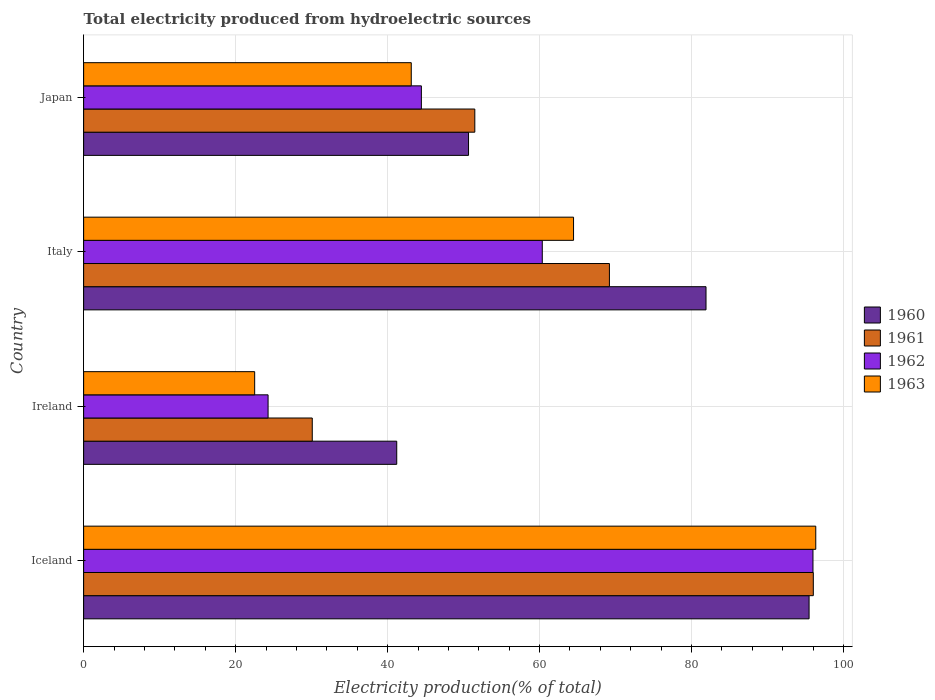How many groups of bars are there?
Give a very brief answer. 4. Are the number of bars per tick equal to the number of legend labels?
Provide a short and direct response. Yes. Are the number of bars on each tick of the Y-axis equal?
Keep it short and to the point. Yes. What is the label of the 3rd group of bars from the top?
Make the answer very short. Ireland. What is the total electricity produced in 1961 in Iceland?
Your answer should be very brief. 96.02. Across all countries, what is the maximum total electricity produced in 1962?
Your answer should be compact. 95.97. Across all countries, what is the minimum total electricity produced in 1962?
Offer a very short reply. 24.27. In which country was the total electricity produced in 1963 minimum?
Your response must be concise. Ireland. What is the total total electricity produced in 1960 in the graph?
Ensure brevity in your answer.  269.21. What is the difference between the total electricity produced in 1960 in Italy and that in Japan?
Your answer should be compact. 31.25. What is the difference between the total electricity produced in 1962 in Japan and the total electricity produced in 1960 in Iceland?
Offer a terse response. -51.02. What is the average total electricity produced in 1960 per country?
Provide a short and direct response. 67.3. What is the difference between the total electricity produced in 1963 and total electricity produced in 1962 in Ireland?
Make the answer very short. -1.76. What is the ratio of the total electricity produced in 1960 in Iceland to that in Japan?
Your answer should be compact. 1.88. What is the difference between the highest and the second highest total electricity produced in 1963?
Your answer should be very brief. 31.87. What is the difference between the highest and the lowest total electricity produced in 1963?
Your answer should be very brief. 73.83. Is the sum of the total electricity produced in 1961 in Italy and Japan greater than the maximum total electricity produced in 1963 across all countries?
Provide a short and direct response. Yes. What does the 3rd bar from the top in Japan represents?
Provide a succinct answer. 1961. Is it the case that in every country, the sum of the total electricity produced in 1962 and total electricity produced in 1963 is greater than the total electricity produced in 1960?
Offer a terse response. Yes. How are the legend labels stacked?
Give a very brief answer. Vertical. What is the title of the graph?
Make the answer very short. Total electricity produced from hydroelectric sources. What is the label or title of the X-axis?
Make the answer very short. Electricity production(% of total). What is the Electricity production(% of total) in 1960 in Iceland?
Keep it short and to the point. 95.46. What is the Electricity production(% of total) in 1961 in Iceland?
Ensure brevity in your answer.  96.02. What is the Electricity production(% of total) in 1962 in Iceland?
Provide a succinct answer. 95.97. What is the Electricity production(% of total) in 1963 in Iceland?
Give a very brief answer. 96.34. What is the Electricity production(% of total) in 1960 in Ireland?
Ensure brevity in your answer.  41.2. What is the Electricity production(% of total) of 1961 in Ireland?
Provide a short and direct response. 30.09. What is the Electricity production(% of total) of 1962 in Ireland?
Provide a succinct answer. 24.27. What is the Electricity production(% of total) of 1963 in Ireland?
Offer a very short reply. 22.51. What is the Electricity production(% of total) of 1960 in Italy?
Keep it short and to the point. 81.9. What is the Electricity production(% of total) in 1961 in Italy?
Provide a succinct answer. 69.19. What is the Electricity production(% of total) in 1962 in Italy?
Your response must be concise. 60.35. What is the Electricity production(% of total) in 1963 in Italy?
Offer a terse response. 64.47. What is the Electricity production(% of total) of 1960 in Japan?
Offer a very short reply. 50.65. What is the Electricity production(% of total) of 1961 in Japan?
Your response must be concise. 51.48. What is the Electricity production(% of total) of 1962 in Japan?
Offer a terse response. 44.44. What is the Electricity production(% of total) in 1963 in Japan?
Provide a succinct answer. 43.11. Across all countries, what is the maximum Electricity production(% of total) of 1960?
Provide a succinct answer. 95.46. Across all countries, what is the maximum Electricity production(% of total) in 1961?
Offer a terse response. 96.02. Across all countries, what is the maximum Electricity production(% of total) of 1962?
Your response must be concise. 95.97. Across all countries, what is the maximum Electricity production(% of total) in 1963?
Provide a short and direct response. 96.34. Across all countries, what is the minimum Electricity production(% of total) of 1960?
Your response must be concise. 41.2. Across all countries, what is the minimum Electricity production(% of total) of 1961?
Give a very brief answer. 30.09. Across all countries, what is the minimum Electricity production(% of total) in 1962?
Give a very brief answer. 24.27. Across all countries, what is the minimum Electricity production(% of total) in 1963?
Ensure brevity in your answer.  22.51. What is the total Electricity production(% of total) of 1960 in the graph?
Ensure brevity in your answer.  269.21. What is the total Electricity production(% of total) in 1961 in the graph?
Provide a short and direct response. 246.77. What is the total Electricity production(% of total) of 1962 in the graph?
Give a very brief answer. 225.05. What is the total Electricity production(% of total) of 1963 in the graph?
Keep it short and to the point. 226.43. What is the difference between the Electricity production(% of total) in 1960 in Iceland and that in Ireland?
Give a very brief answer. 54.26. What is the difference between the Electricity production(% of total) of 1961 in Iceland and that in Ireland?
Your answer should be very brief. 65.93. What is the difference between the Electricity production(% of total) in 1962 in Iceland and that in Ireland?
Ensure brevity in your answer.  71.7. What is the difference between the Electricity production(% of total) of 1963 in Iceland and that in Ireland?
Make the answer very short. 73.83. What is the difference between the Electricity production(% of total) in 1960 in Iceland and that in Italy?
Your answer should be compact. 13.56. What is the difference between the Electricity production(% of total) of 1961 in Iceland and that in Italy?
Ensure brevity in your answer.  26.83. What is the difference between the Electricity production(% of total) in 1962 in Iceland and that in Italy?
Your answer should be compact. 35.62. What is the difference between the Electricity production(% of total) in 1963 in Iceland and that in Italy?
Ensure brevity in your answer.  31.87. What is the difference between the Electricity production(% of total) of 1960 in Iceland and that in Japan?
Your answer should be compact. 44.81. What is the difference between the Electricity production(% of total) of 1961 in Iceland and that in Japan?
Ensure brevity in your answer.  44.54. What is the difference between the Electricity production(% of total) of 1962 in Iceland and that in Japan?
Give a very brief answer. 51.53. What is the difference between the Electricity production(% of total) in 1963 in Iceland and that in Japan?
Your answer should be compact. 53.23. What is the difference between the Electricity production(% of total) of 1960 in Ireland and that in Italy?
Keep it short and to the point. -40.7. What is the difference between the Electricity production(% of total) in 1961 in Ireland and that in Italy?
Your answer should be compact. -39.1. What is the difference between the Electricity production(% of total) of 1962 in Ireland and that in Italy?
Give a very brief answer. -36.08. What is the difference between the Electricity production(% of total) of 1963 in Ireland and that in Italy?
Offer a very short reply. -41.96. What is the difference between the Electricity production(% of total) in 1960 in Ireland and that in Japan?
Keep it short and to the point. -9.45. What is the difference between the Electricity production(% of total) of 1961 in Ireland and that in Japan?
Offer a terse response. -21.39. What is the difference between the Electricity production(% of total) in 1962 in Ireland and that in Japan?
Provide a succinct answer. -20.17. What is the difference between the Electricity production(% of total) of 1963 in Ireland and that in Japan?
Make the answer very short. -20.61. What is the difference between the Electricity production(% of total) of 1960 in Italy and that in Japan?
Your answer should be very brief. 31.25. What is the difference between the Electricity production(% of total) in 1961 in Italy and that in Japan?
Provide a succinct answer. 17.71. What is the difference between the Electricity production(% of total) in 1962 in Italy and that in Japan?
Provide a short and direct response. 15.91. What is the difference between the Electricity production(% of total) in 1963 in Italy and that in Japan?
Provide a succinct answer. 21.35. What is the difference between the Electricity production(% of total) in 1960 in Iceland and the Electricity production(% of total) in 1961 in Ireland?
Make the answer very short. 65.38. What is the difference between the Electricity production(% of total) in 1960 in Iceland and the Electricity production(% of total) in 1962 in Ireland?
Offer a very short reply. 71.19. What is the difference between the Electricity production(% of total) in 1960 in Iceland and the Electricity production(% of total) in 1963 in Ireland?
Your answer should be very brief. 72.95. What is the difference between the Electricity production(% of total) of 1961 in Iceland and the Electricity production(% of total) of 1962 in Ireland?
Your answer should be compact. 71.75. What is the difference between the Electricity production(% of total) in 1961 in Iceland and the Electricity production(% of total) in 1963 in Ireland?
Provide a short and direct response. 73.51. What is the difference between the Electricity production(% of total) in 1962 in Iceland and the Electricity production(% of total) in 1963 in Ireland?
Keep it short and to the point. 73.47. What is the difference between the Electricity production(% of total) in 1960 in Iceland and the Electricity production(% of total) in 1961 in Italy?
Provide a succinct answer. 26.27. What is the difference between the Electricity production(% of total) in 1960 in Iceland and the Electricity production(% of total) in 1962 in Italy?
Your response must be concise. 35.11. What is the difference between the Electricity production(% of total) in 1960 in Iceland and the Electricity production(% of total) in 1963 in Italy?
Offer a very short reply. 30.99. What is the difference between the Electricity production(% of total) in 1961 in Iceland and the Electricity production(% of total) in 1962 in Italy?
Provide a succinct answer. 35.67. What is the difference between the Electricity production(% of total) of 1961 in Iceland and the Electricity production(% of total) of 1963 in Italy?
Provide a succinct answer. 31.55. What is the difference between the Electricity production(% of total) of 1962 in Iceland and the Electricity production(% of total) of 1963 in Italy?
Give a very brief answer. 31.51. What is the difference between the Electricity production(% of total) of 1960 in Iceland and the Electricity production(% of total) of 1961 in Japan?
Give a very brief answer. 43.99. What is the difference between the Electricity production(% of total) in 1960 in Iceland and the Electricity production(% of total) in 1962 in Japan?
Ensure brevity in your answer.  51.02. What is the difference between the Electricity production(% of total) of 1960 in Iceland and the Electricity production(% of total) of 1963 in Japan?
Your answer should be very brief. 52.35. What is the difference between the Electricity production(% of total) in 1961 in Iceland and the Electricity production(% of total) in 1962 in Japan?
Offer a terse response. 51.58. What is the difference between the Electricity production(% of total) of 1961 in Iceland and the Electricity production(% of total) of 1963 in Japan?
Your answer should be very brief. 52.91. What is the difference between the Electricity production(% of total) of 1962 in Iceland and the Electricity production(% of total) of 1963 in Japan?
Keep it short and to the point. 52.86. What is the difference between the Electricity production(% of total) in 1960 in Ireland and the Electricity production(% of total) in 1961 in Italy?
Your answer should be very brief. -27.99. What is the difference between the Electricity production(% of total) in 1960 in Ireland and the Electricity production(% of total) in 1962 in Italy?
Make the answer very short. -19.15. What is the difference between the Electricity production(% of total) in 1960 in Ireland and the Electricity production(% of total) in 1963 in Italy?
Ensure brevity in your answer.  -23.27. What is the difference between the Electricity production(% of total) of 1961 in Ireland and the Electricity production(% of total) of 1962 in Italy?
Give a very brief answer. -30.27. What is the difference between the Electricity production(% of total) of 1961 in Ireland and the Electricity production(% of total) of 1963 in Italy?
Make the answer very short. -34.38. What is the difference between the Electricity production(% of total) in 1962 in Ireland and the Electricity production(% of total) in 1963 in Italy?
Provide a succinct answer. -40.2. What is the difference between the Electricity production(% of total) of 1960 in Ireland and the Electricity production(% of total) of 1961 in Japan?
Ensure brevity in your answer.  -10.27. What is the difference between the Electricity production(% of total) of 1960 in Ireland and the Electricity production(% of total) of 1962 in Japan?
Offer a very short reply. -3.24. What is the difference between the Electricity production(% of total) of 1960 in Ireland and the Electricity production(% of total) of 1963 in Japan?
Give a very brief answer. -1.91. What is the difference between the Electricity production(% of total) of 1961 in Ireland and the Electricity production(% of total) of 1962 in Japan?
Make the answer very short. -14.36. What is the difference between the Electricity production(% of total) in 1961 in Ireland and the Electricity production(% of total) in 1963 in Japan?
Your response must be concise. -13.03. What is the difference between the Electricity production(% of total) in 1962 in Ireland and the Electricity production(% of total) in 1963 in Japan?
Offer a very short reply. -18.84. What is the difference between the Electricity production(% of total) in 1960 in Italy and the Electricity production(% of total) in 1961 in Japan?
Ensure brevity in your answer.  30.42. What is the difference between the Electricity production(% of total) in 1960 in Italy and the Electricity production(% of total) in 1962 in Japan?
Keep it short and to the point. 37.46. What is the difference between the Electricity production(% of total) in 1960 in Italy and the Electricity production(% of total) in 1963 in Japan?
Provide a short and direct response. 38.79. What is the difference between the Electricity production(% of total) of 1961 in Italy and the Electricity production(% of total) of 1962 in Japan?
Make the answer very short. 24.75. What is the difference between the Electricity production(% of total) of 1961 in Italy and the Electricity production(% of total) of 1963 in Japan?
Offer a very short reply. 26.08. What is the difference between the Electricity production(% of total) of 1962 in Italy and the Electricity production(% of total) of 1963 in Japan?
Your response must be concise. 17.24. What is the average Electricity production(% of total) of 1960 per country?
Provide a succinct answer. 67.3. What is the average Electricity production(% of total) in 1961 per country?
Your answer should be very brief. 61.69. What is the average Electricity production(% of total) in 1962 per country?
Provide a succinct answer. 56.26. What is the average Electricity production(% of total) of 1963 per country?
Provide a short and direct response. 56.61. What is the difference between the Electricity production(% of total) in 1960 and Electricity production(% of total) in 1961 in Iceland?
Make the answer very short. -0.56. What is the difference between the Electricity production(% of total) of 1960 and Electricity production(% of total) of 1962 in Iceland?
Provide a succinct answer. -0.51. What is the difference between the Electricity production(% of total) of 1960 and Electricity production(% of total) of 1963 in Iceland?
Your response must be concise. -0.88. What is the difference between the Electricity production(% of total) of 1961 and Electricity production(% of total) of 1962 in Iceland?
Offer a very short reply. 0.05. What is the difference between the Electricity production(% of total) of 1961 and Electricity production(% of total) of 1963 in Iceland?
Make the answer very short. -0.32. What is the difference between the Electricity production(% of total) in 1962 and Electricity production(% of total) in 1963 in Iceland?
Your response must be concise. -0.37. What is the difference between the Electricity production(% of total) of 1960 and Electricity production(% of total) of 1961 in Ireland?
Offer a terse response. 11.12. What is the difference between the Electricity production(% of total) in 1960 and Electricity production(% of total) in 1962 in Ireland?
Keep it short and to the point. 16.93. What is the difference between the Electricity production(% of total) in 1960 and Electricity production(% of total) in 1963 in Ireland?
Offer a terse response. 18.69. What is the difference between the Electricity production(% of total) of 1961 and Electricity production(% of total) of 1962 in Ireland?
Your response must be concise. 5.81. What is the difference between the Electricity production(% of total) in 1961 and Electricity production(% of total) in 1963 in Ireland?
Provide a succinct answer. 7.58. What is the difference between the Electricity production(% of total) of 1962 and Electricity production(% of total) of 1963 in Ireland?
Offer a terse response. 1.76. What is the difference between the Electricity production(% of total) in 1960 and Electricity production(% of total) in 1961 in Italy?
Make the answer very short. 12.71. What is the difference between the Electricity production(% of total) in 1960 and Electricity production(% of total) in 1962 in Italy?
Make the answer very short. 21.55. What is the difference between the Electricity production(% of total) of 1960 and Electricity production(% of total) of 1963 in Italy?
Give a very brief answer. 17.43. What is the difference between the Electricity production(% of total) of 1961 and Electricity production(% of total) of 1962 in Italy?
Your answer should be very brief. 8.84. What is the difference between the Electricity production(% of total) in 1961 and Electricity production(% of total) in 1963 in Italy?
Offer a terse response. 4.72. What is the difference between the Electricity production(% of total) of 1962 and Electricity production(% of total) of 1963 in Italy?
Your answer should be very brief. -4.11. What is the difference between the Electricity production(% of total) of 1960 and Electricity production(% of total) of 1961 in Japan?
Keep it short and to the point. -0.83. What is the difference between the Electricity production(% of total) in 1960 and Electricity production(% of total) in 1962 in Japan?
Ensure brevity in your answer.  6.2. What is the difference between the Electricity production(% of total) of 1960 and Electricity production(% of total) of 1963 in Japan?
Make the answer very short. 7.54. What is the difference between the Electricity production(% of total) of 1961 and Electricity production(% of total) of 1962 in Japan?
Provide a short and direct response. 7.03. What is the difference between the Electricity production(% of total) in 1961 and Electricity production(% of total) in 1963 in Japan?
Your response must be concise. 8.36. What is the difference between the Electricity production(% of total) of 1962 and Electricity production(% of total) of 1963 in Japan?
Offer a terse response. 1.33. What is the ratio of the Electricity production(% of total) of 1960 in Iceland to that in Ireland?
Ensure brevity in your answer.  2.32. What is the ratio of the Electricity production(% of total) in 1961 in Iceland to that in Ireland?
Keep it short and to the point. 3.19. What is the ratio of the Electricity production(% of total) in 1962 in Iceland to that in Ireland?
Make the answer very short. 3.95. What is the ratio of the Electricity production(% of total) in 1963 in Iceland to that in Ireland?
Your answer should be very brief. 4.28. What is the ratio of the Electricity production(% of total) in 1960 in Iceland to that in Italy?
Give a very brief answer. 1.17. What is the ratio of the Electricity production(% of total) in 1961 in Iceland to that in Italy?
Your answer should be very brief. 1.39. What is the ratio of the Electricity production(% of total) in 1962 in Iceland to that in Italy?
Your response must be concise. 1.59. What is the ratio of the Electricity production(% of total) of 1963 in Iceland to that in Italy?
Offer a very short reply. 1.49. What is the ratio of the Electricity production(% of total) of 1960 in Iceland to that in Japan?
Your answer should be compact. 1.88. What is the ratio of the Electricity production(% of total) in 1961 in Iceland to that in Japan?
Give a very brief answer. 1.87. What is the ratio of the Electricity production(% of total) in 1962 in Iceland to that in Japan?
Provide a short and direct response. 2.16. What is the ratio of the Electricity production(% of total) of 1963 in Iceland to that in Japan?
Your response must be concise. 2.23. What is the ratio of the Electricity production(% of total) in 1960 in Ireland to that in Italy?
Give a very brief answer. 0.5. What is the ratio of the Electricity production(% of total) in 1961 in Ireland to that in Italy?
Your response must be concise. 0.43. What is the ratio of the Electricity production(% of total) in 1962 in Ireland to that in Italy?
Your response must be concise. 0.4. What is the ratio of the Electricity production(% of total) in 1963 in Ireland to that in Italy?
Your response must be concise. 0.35. What is the ratio of the Electricity production(% of total) of 1960 in Ireland to that in Japan?
Offer a very short reply. 0.81. What is the ratio of the Electricity production(% of total) of 1961 in Ireland to that in Japan?
Your answer should be very brief. 0.58. What is the ratio of the Electricity production(% of total) of 1962 in Ireland to that in Japan?
Your answer should be very brief. 0.55. What is the ratio of the Electricity production(% of total) in 1963 in Ireland to that in Japan?
Keep it short and to the point. 0.52. What is the ratio of the Electricity production(% of total) of 1960 in Italy to that in Japan?
Provide a succinct answer. 1.62. What is the ratio of the Electricity production(% of total) of 1961 in Italy to that in Japan?
Ensure brevity in your answer.  1.34. What is the ratio of the Electricity production(% of total) in 1962 in Italy to that in Japan?
Your response must be concise. 1.36. What is the ratio of the Electricity production(% of total) of 1963 in Italy to that in Japan?
Your response must be concise. 1.5. What is the difference between the highest and the second highest Electricity production(% of total) of 1960?
Provide a succinct answer. 13.56. What is the difference between the highest and the second highest Electricity production(% of total) in 1961?
Provide a succinct answer. 26.83. What is the difference between the highest and the second highest Electricity production(% of total) in 1962?
Your answer should be very brief. 35.62. What is the difference between the highest and the second highest Electricity production(% of total) in 1963?
Your answer should be compact. 31.87. What is the difference between the highest and the lowest Electricity production(% of total) of 1960?
Provide a short and direct response. 54.26. What is the difference between the highest and the lowest Electricity production(% of total) of 1961?
Offer a terse response. 65.93. What is the difference between the highest and the lowest Electricity production(% of total) of 1962?
Ensure brevity in your answer.  71.7. What is the difference between the highest and the lowest Electricity production(% of total) of 1963?
Keep it short and to the point. 73.83. 